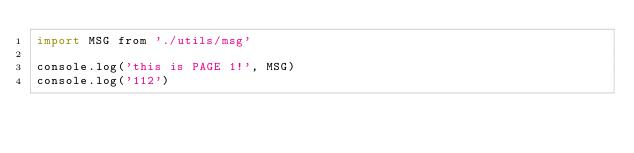Convert code to text. <code><loc_0><loc_0><loc_500><loc_500><_JavaScript_>import MSG from './utils/msg'

console.log('this is PAGE 1!', MSG)
console.log('112')
</code> 